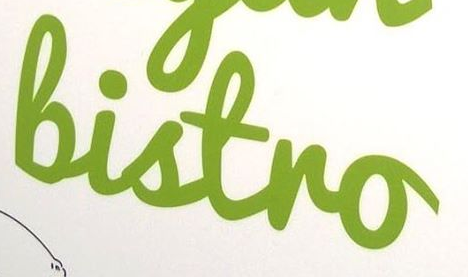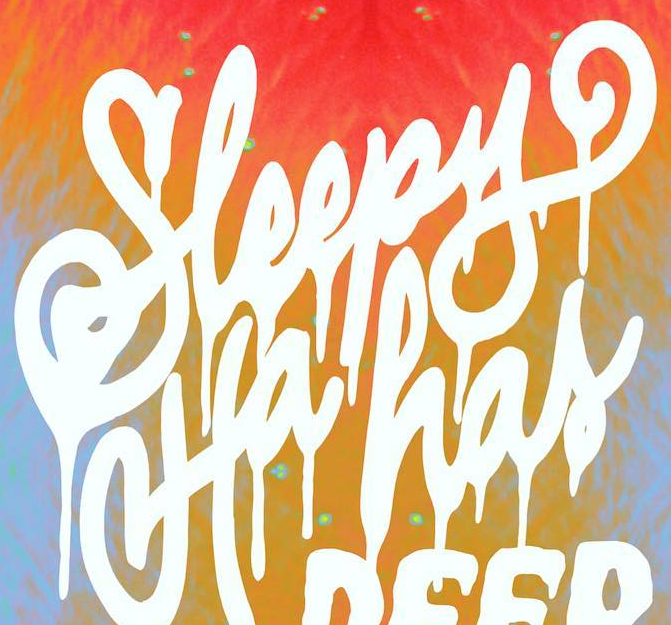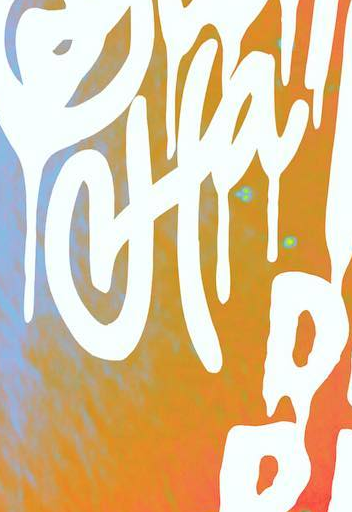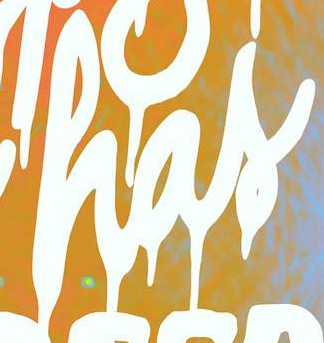What text is displayed in these images sequentially, separated by a semicolon? Bistro; Sleepy; Ha; has 